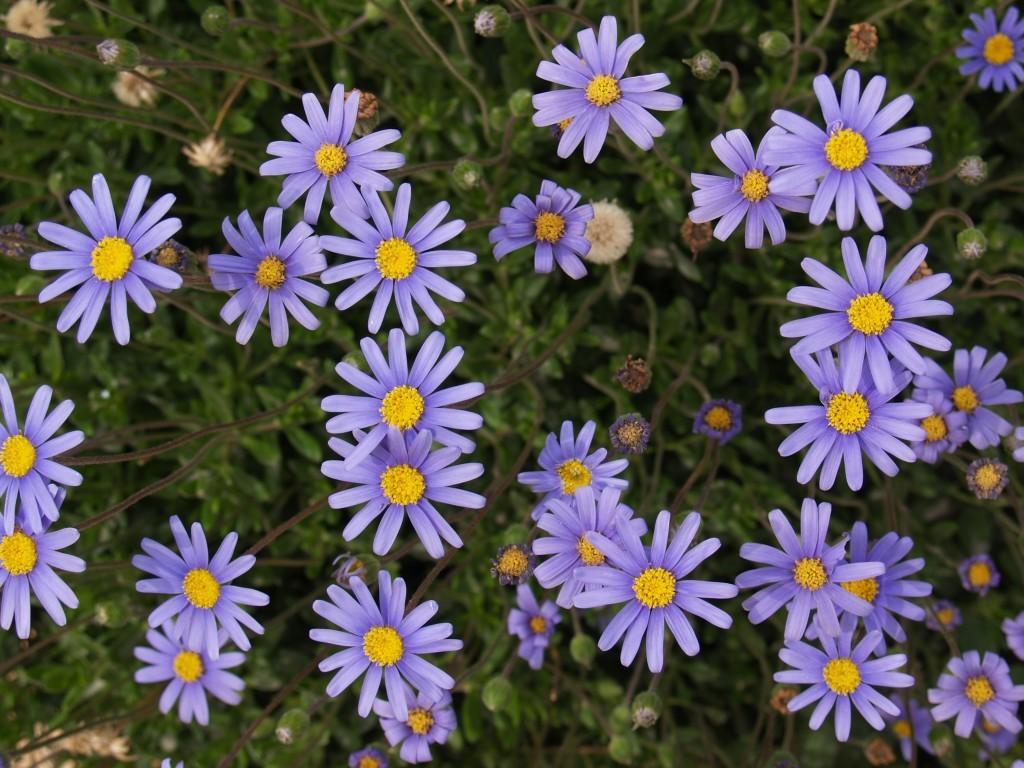Describe this image in one or two sentences. In this image I can see the flowers to the plants. These flowers are in purple and yellow color. And the plants are in green color. 